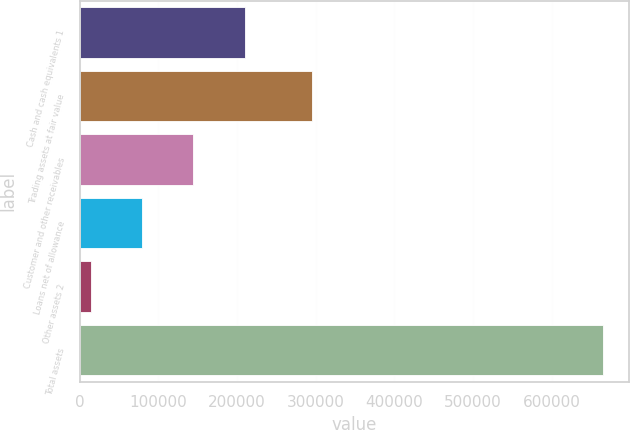Convert chart. <chart><loc_0><loc_0><loc_500><loc_500><bar_chart><fcel>Cash and cash equivalents 1<fcel>Trading assets at fair value<fcel>Customer and other receivables<fcel>Loans net of allowance<fcel>Other assets 2<fcel>Total assets<nl><fcel>209686<fcel>295678<fcel>144645<fcel>79604.1<fcel>14563<fcel>664974<nl></chart> 